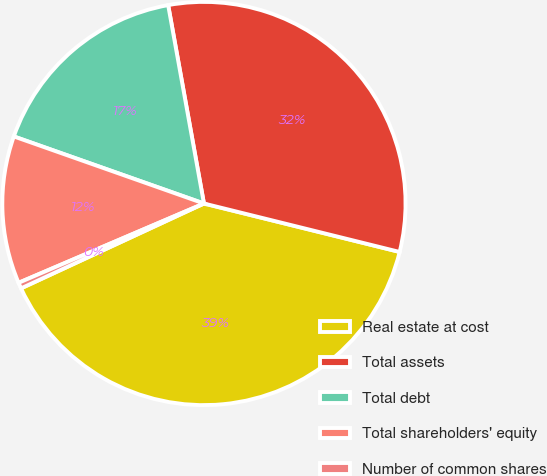Convert chart to OTSL. <chart><loc_0><loc_0><loc_500><loc_500><pie_chart><fcel>Real estate at cost<fcel>Total assets<fcel>Total debt<fcel>Total shareholders' equity<fcel>Number of common shares<nl><fcel>39.22%<fcel>31.7%<fcel>16.76%<fcel>11.83%<fcel>0.48%<nl></chart> 